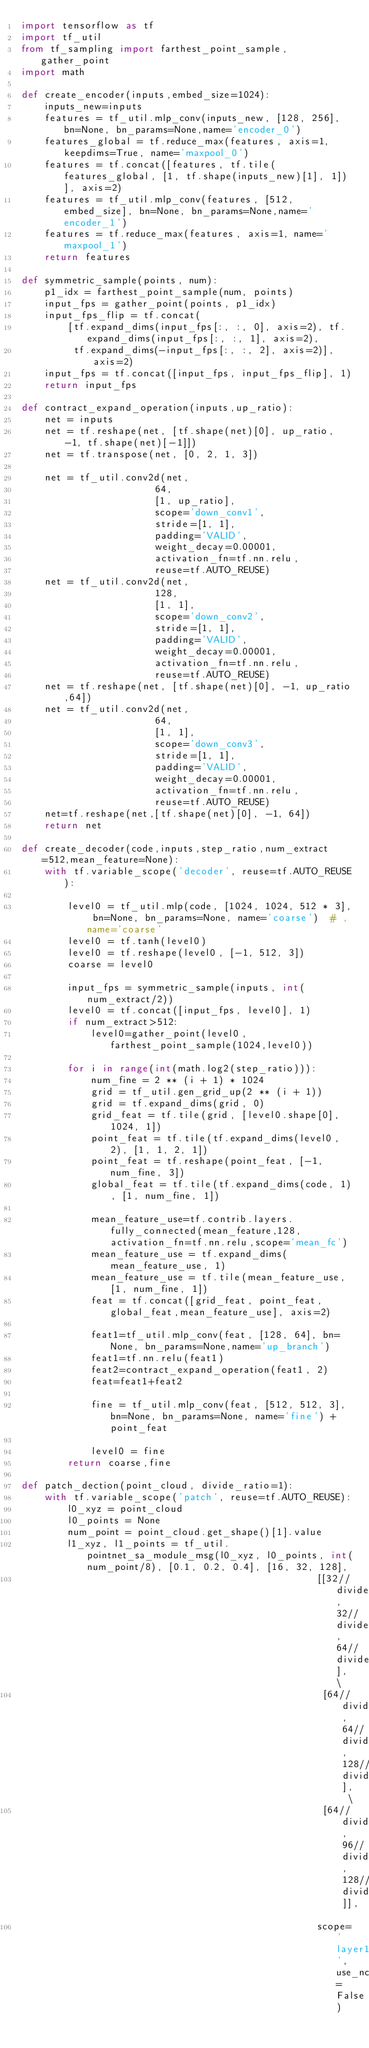<code> <loc_0><loc_0><loc_500><loc_500><_Python_>import tensorflow as tf
import tf_util
from tf_sampling import farthest_point_sample, gather_point
import math

def create_encoder(inputs,embed_size=1024):
    inputs_new=inputs
    features = tf_util.mlp_conv(inputs_new, [128, 256], bn=None, bn_params=None,name='encoder_0')
    features_global = tf.reduce_max(features, axis=1, keepdims=True, name='maxpool_0')
    features = tf.concat([features, tf.tile(features_global, [1, tf.shape(inputs_new)[1], 1])], axis=2)
    features = tf_util.mlp_conv(features, [512, embed_size], bn=None, bn_params=None,name='encoder_1')
    features = tf.reduce_max(features, axis=1, name='maxpool_1')
    return features

def symmetric_sample(points, num):
    p1_idx = farthest_point_sample(num, points)
    input_fps = gather_point(points, p1_idx)
    input_fps_flip = tf.concat(
        [tf.expand_dims(input_fps[:, :, 0], axis=2), tf.expand_dims(input_fps[:, :, 1], axis=2),
         tf.expand_dims(-input_fps[:, :, 2], axis=2)], axis=2)
    input_fps = tf.concat([input_fps, input_fps_flip], 1)
    return input_fps

def contract_expand_operation(inputs,up_ratio):
    net = inputs
    net = tf.reshape(net, [tf.shape(net)[0], up_ratio, -1, tf.shape(net)[-1]])
    net = tf.transpose(net, [0, 2, 1, 3])

    net = tf_util.conv2d(net,
                       64,
                       [1, up_ratio],
                       scope='down_conv1',
                       stride=[1, 1],
                       padding='VALID',
                       weight_decay=0.00001,
                       activation_fn=tf.nn.relu,
                       reuse=tf.AUTO_REUSE)
    net = tf_util.conv2d(net,
                       128,
                       [1, 1],
                       scope='down_conv2',
                       stride=[1, 1],
                       padding='VALID',
                       weight_decay=0.00001,
                       activation_fn=tf.nn.relu,
                       reuse=tf.AUTO_REUSE)
    net = tf.reshape(net, [tf.shape(net)[0], -1, up_ratio,64])
    net = tf_util.conv2d(net,
                       64,
                       [1, 1],
                       scope='down_conv3',
                       stride=[1, 1],
                       padding='VALID',
                       weight_decay=0.00001,
                       activation_fn=tf.nn.relu,
                       reuse=tf.AUTO_REUSE)
    net=tf.reshape(net,[tf.shape(net)[0], -1, 64])
    return net

def create_decoder(code,inputs,step_ratio,num_extract=512,mean_feature=None):
    with tf.variable_scope('decoder', reuse=tf.AUTO_REUSE):

        level0 = tf_util.mlp(code, [1024, 1024, 512 * 3], bn=None, bn_params=None, name='coarse')  # ,name='coarse'
        level0 = tf.tanh(level0)
        level0 = tf.reshape(level0, [-1, 512, 3])
        coarse = level0

        input_fps = symmetric_sample(inputs, int(num_extract/2))
        level0 = tf.concat([input_fps, level0], 1)
        if num_extract>512:
            level0=gather_point(level0,farthest_point_sample(1024,level0))

        for i in range(int(math.log2(step_ratio))):
            num_fine = 2 ** (i + 1) * 1024
            grid = tf_util.gen_grid_up(2 ** (i + 1))
            grid = tf.expand_dims(grid, 0)
            grid_feat = tf.tile(grid, [level0.shape[0], 1024, 1])
            point_feat = tf.tile(tf.expand_dims(level0, 2), [1, 1, 2, 1])
            point_feat = tf.reshape(point_feat, [-1, num_fine, 3])
            global_feat = tf.tile(tf.expand_dims(code, 1), [1, num_fine, 1])

            mean_feature_use=tf.contrib.layers.fully_connected(mean_feature,128,activation_fn=tf.nn.relu,scope='mean_fc')
            mean_feature_use = tf.expand_dims(mean_feature_use, 1)
            mean_feature_use = tf.tile(mean_feature_use, [1, num_fine, 1])
            feat = tf.concat([grid_feat, point_feat, global_feat,mean_feature_use], axis=2)

            feat1=tf_util.mlp_conv(feat, [128, 64], bn=None, bn_params=None,name='up_branch')
            feat1=tf.nn.relu(feat1)
            feat2=contract_expand_operation(feat1, 2)
            feat=feat1+feat2

            fine = tf_util.mlp_conv(feat, [512, 512, 3], bn=None, bn_params=None, name='fine') + point_feat

            level0 = fine
        return coarse,fine

def patch_dection(point_cloud, divide_ratio=1):
    with tf.variable_scope('patch', reuse=tf.AUTO_REUSE):
        l0_xyz = point_cloud
        l0_points = None
        num_point = point_cloud.get_shape()[1].value
        l1_xyz, l1_points = tf_util.pointnet_sa_module_msg(l0_xyz, l0_points, int(num_point/8), [0.1, 0.2, 0.4], [16, 32, 128],
                                                   [[32//divide_ratio, 32//divide_ratio, 64//divide_ratio], \
                                                    [64//divide_ratio, 64//divide_ratio, 128//divide_ratio], \
                                                    [64//divide_ratio, 96//divide_ratio, 128//divide_ratio]],
                                                   scope='layer1', use_nchw=False)</code> 